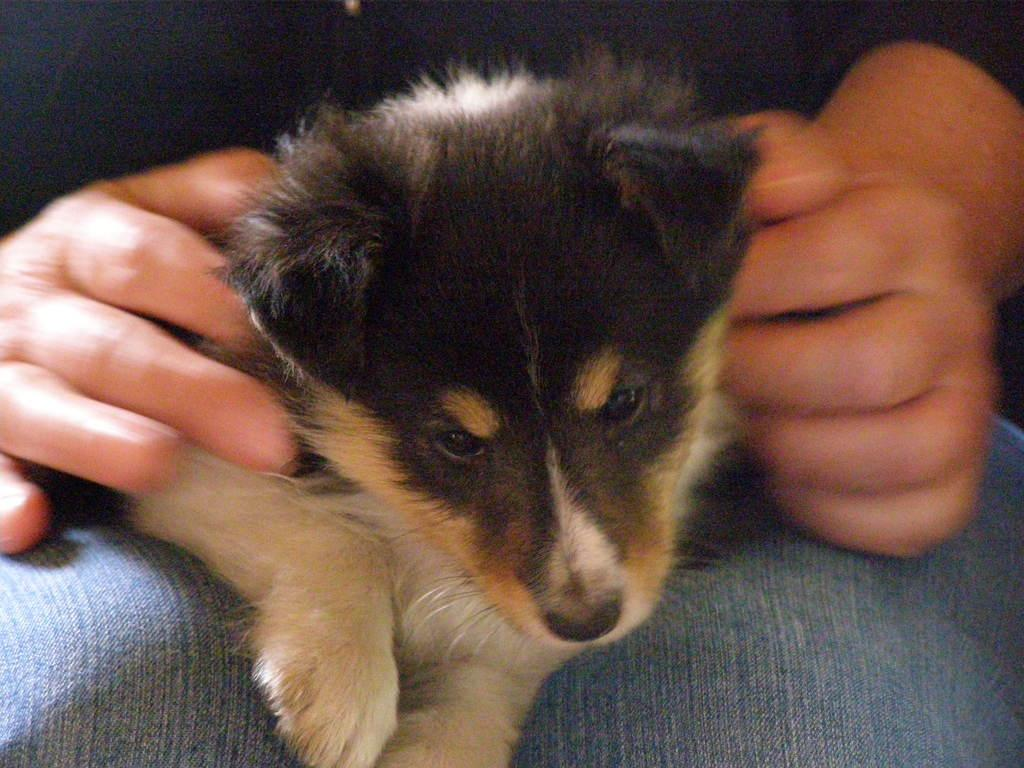Who or what is the main subject in the image? There is a person in the image. What is the person doing in the image? The person is holding a dog. What type of kitten can be seen playing with a quiet surprise in the image? There is no kitten or surprise present in the image; it features a person holding a dog. 